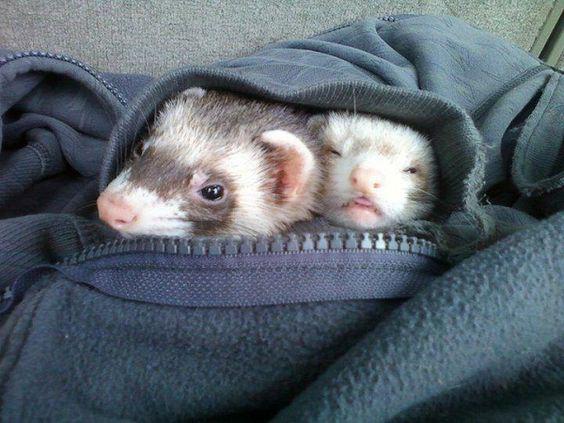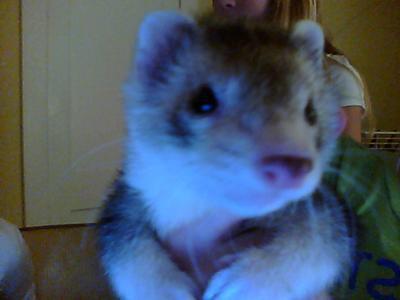The first image is the image on the left, the second image is the image on the right. Examine the images to the left and right. Is the description "One image shows two ferrets sleeping with a cat in between them, and the other shows exactly two animal faces side-by-side." accurate? Answer yes or no. No. The first image is the image on the left, the second image is the image on the right. Assess this claim about the two images: "There is more than one animal species in the image.". Correct or not? Answer yes or no. No. 